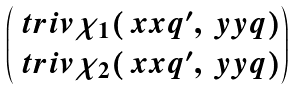Convert formula to latex. <formula><loc_0><loc_0><loc_500><loc_500>\begin{pmatrix} \ t r i v { \chi } _ { 1 } ( \ x x { q } ^ { \prime } , \ y y { q } ) \\ \ t r i v { \chi } _ { 2 } ( \ x x { q } ^ { \prime } , \ y y { q } ) \end{pmatrix}</formula> 